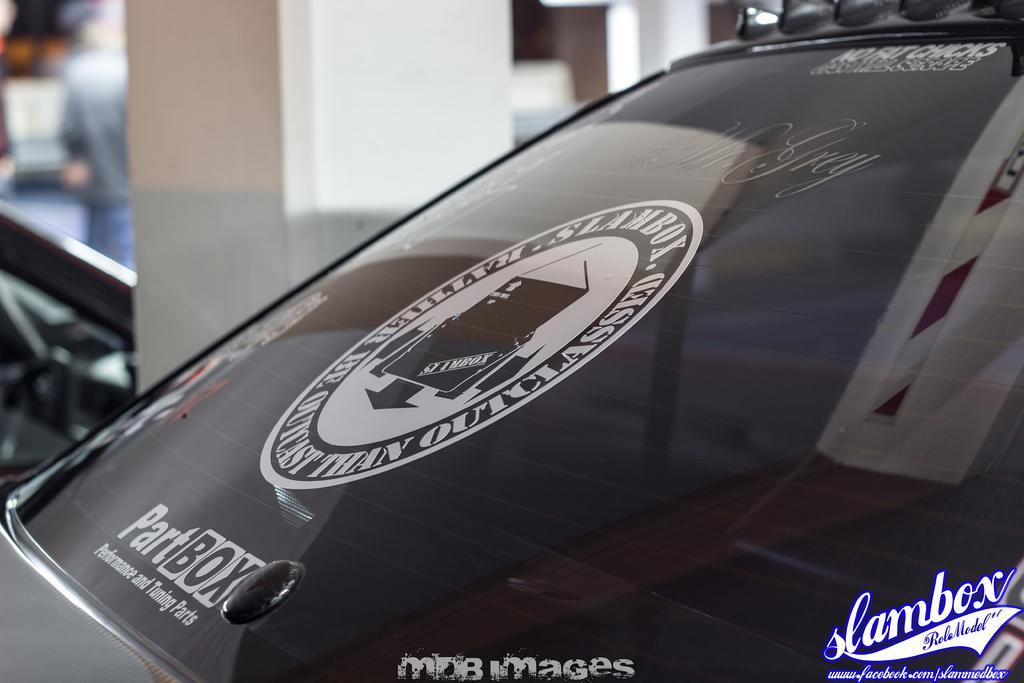Please provide a concise description of this image. In the center of the image a vehicle mirror is there. On mirror a log is there. In the background of the image we can see a pillar, chair and person are there. 